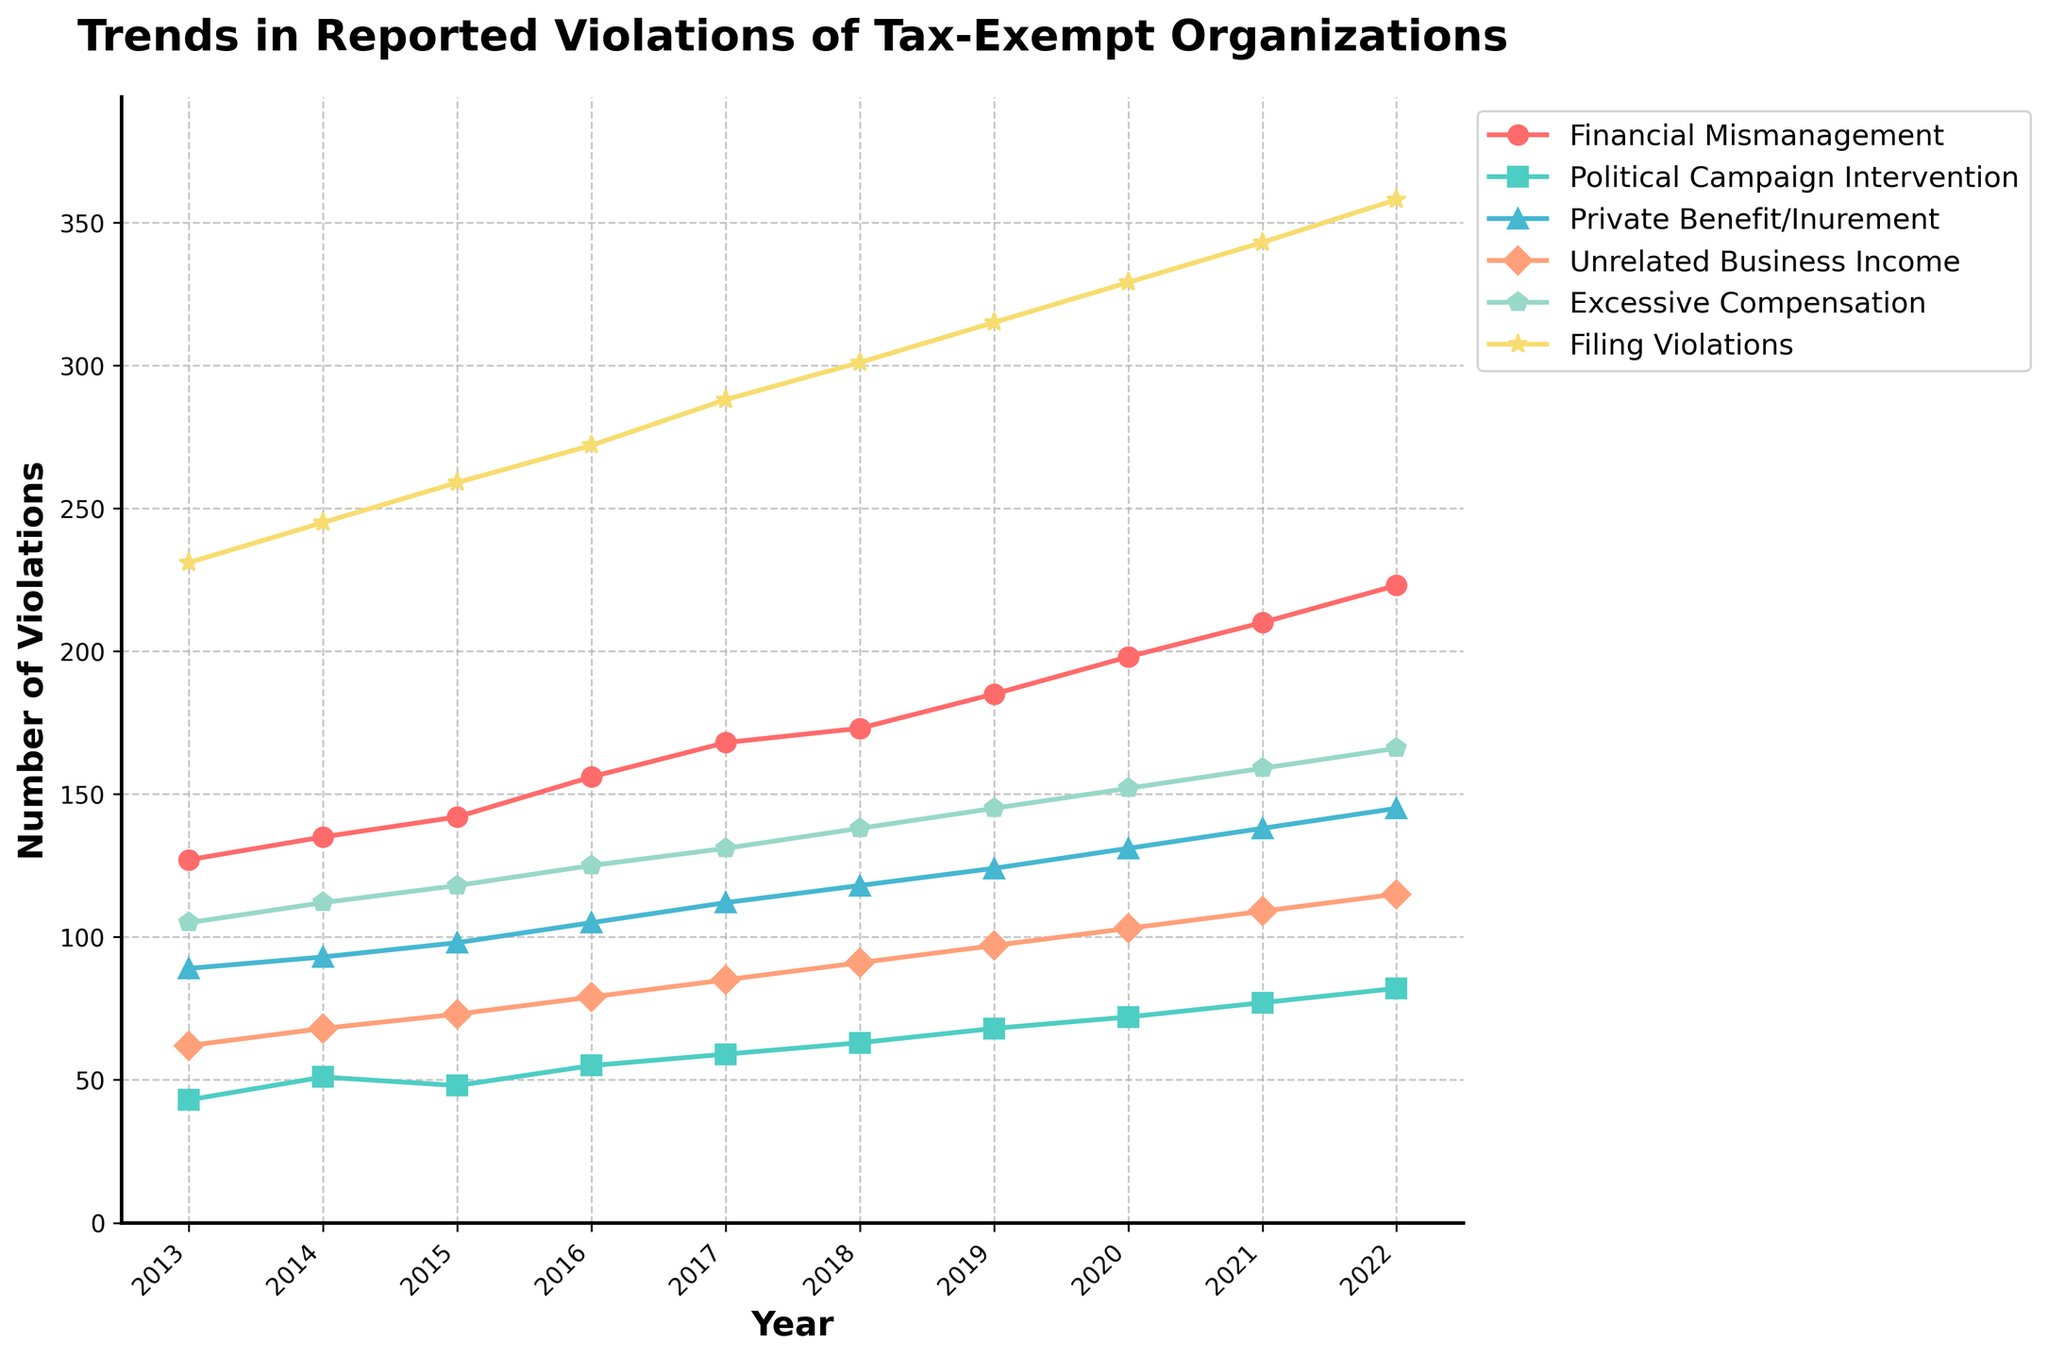What's the trend in 'Filing Violations' from 2013 to 2022? The number of 'Filing Violations' consistently increases from 231 in 2013 to 358 in 2022. Each year, there is a steady rise in the reported violations.
Answer: Increasing trend Which type of violation had the highest number in 2022? Looking at the final points for each line on the right of the chart, 'Filing Violations' had the highest number with 358 violations in 2022.
Answer: Filing Violations What is the difference in 'Financial Mismanagement' violations between 2016 and 2022? In 2016, the 'Financial Mismanagement' violations were 156, and in 2022, they were 223. The difference between these years is 223 - 156 = 67.
Answer: 67 Which violation category shows the least growth over the decade? By examining the slopes of the lines and the overall changes in values, the 'Political Campaign Intervention' category shows the least growth, increasing from 43 in 2013 to 82 in 2022, which is a rise of 39 violations.
Answer: Political Campaign Intervention How does the trend in 'Excessive Compensation' compare to 'Private Benefit/Inurement'? Both categories show an increasing trend, but 'Excessive Compensation' consistently has higher values than 'Private Benefit/Inurement'. 'Excessive Compensation' starts at 105 in 2013 and rises to 166 in 2022, while 'Private Benefit/Inurement' starts at 89 and rises to 145 in the same period.
Answer: Excessive Compensation is consistently higher What is the average number of 'Unrelated Business Income' violations over the 10 years? Sum the values of 'Unrelated Business Income' from 2013 to 2022: 62 + 68 + 73 + 79 + 85 + 91 + 97 + 103 + 109 + 115 = 882. Divide by the number of years (10) to get the average: 882 / 10 = 88.2.
Answer: 88.2 Which category had the most significant increase in reported violations from 2013 to 2022? 'Filing Violations' increased from 231 in 2013 to 358 in 2022. The increase is 358 - 231 = 127, which is the highest among all the categories.
Answer: Filing Violations Between which two consecutive years did 'Political Campaign Intervention' have the largest increase in reported violations? From 2020 to 2021, 'Political Campaign Intervention' increased from 72 to 77, which is a rise of 5 violations.
Answer: 2020 to 2021 